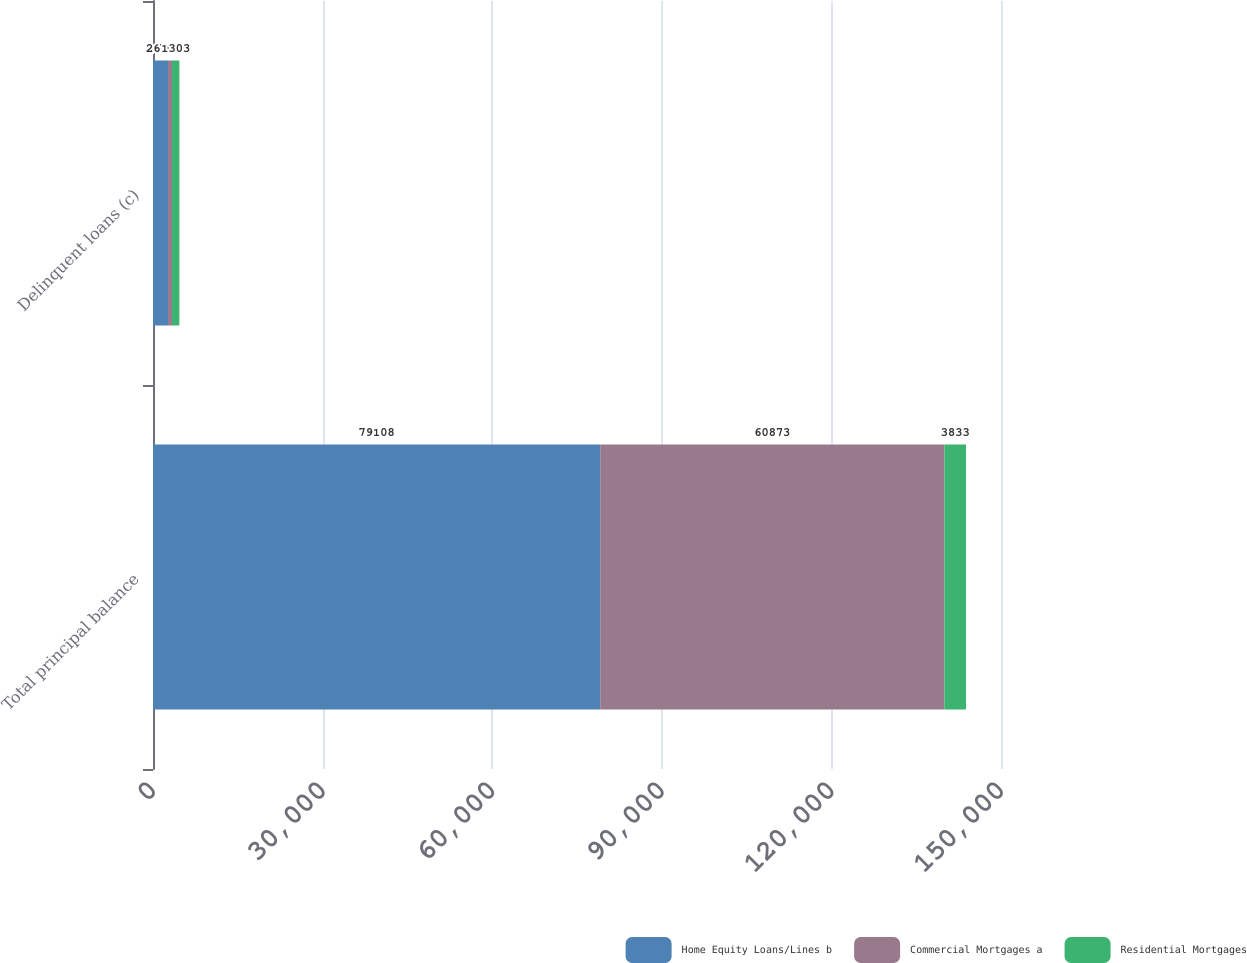<chart> <loc_0><loc_0><loc_500><loc_500><stacked_bar_chart><ecel><fcel>Total principal balance<fcel>Delinquent loans (c)<nl><fcel>Home Equity Loans/Lines b<fcel>79108<fcel>2657<nl><fcel>Commercial Mortgages a<fcel>60873<fcel>707<nl><fcel>Residential Mortgages<fcel>3833<fcel>1303<nl></chart> 